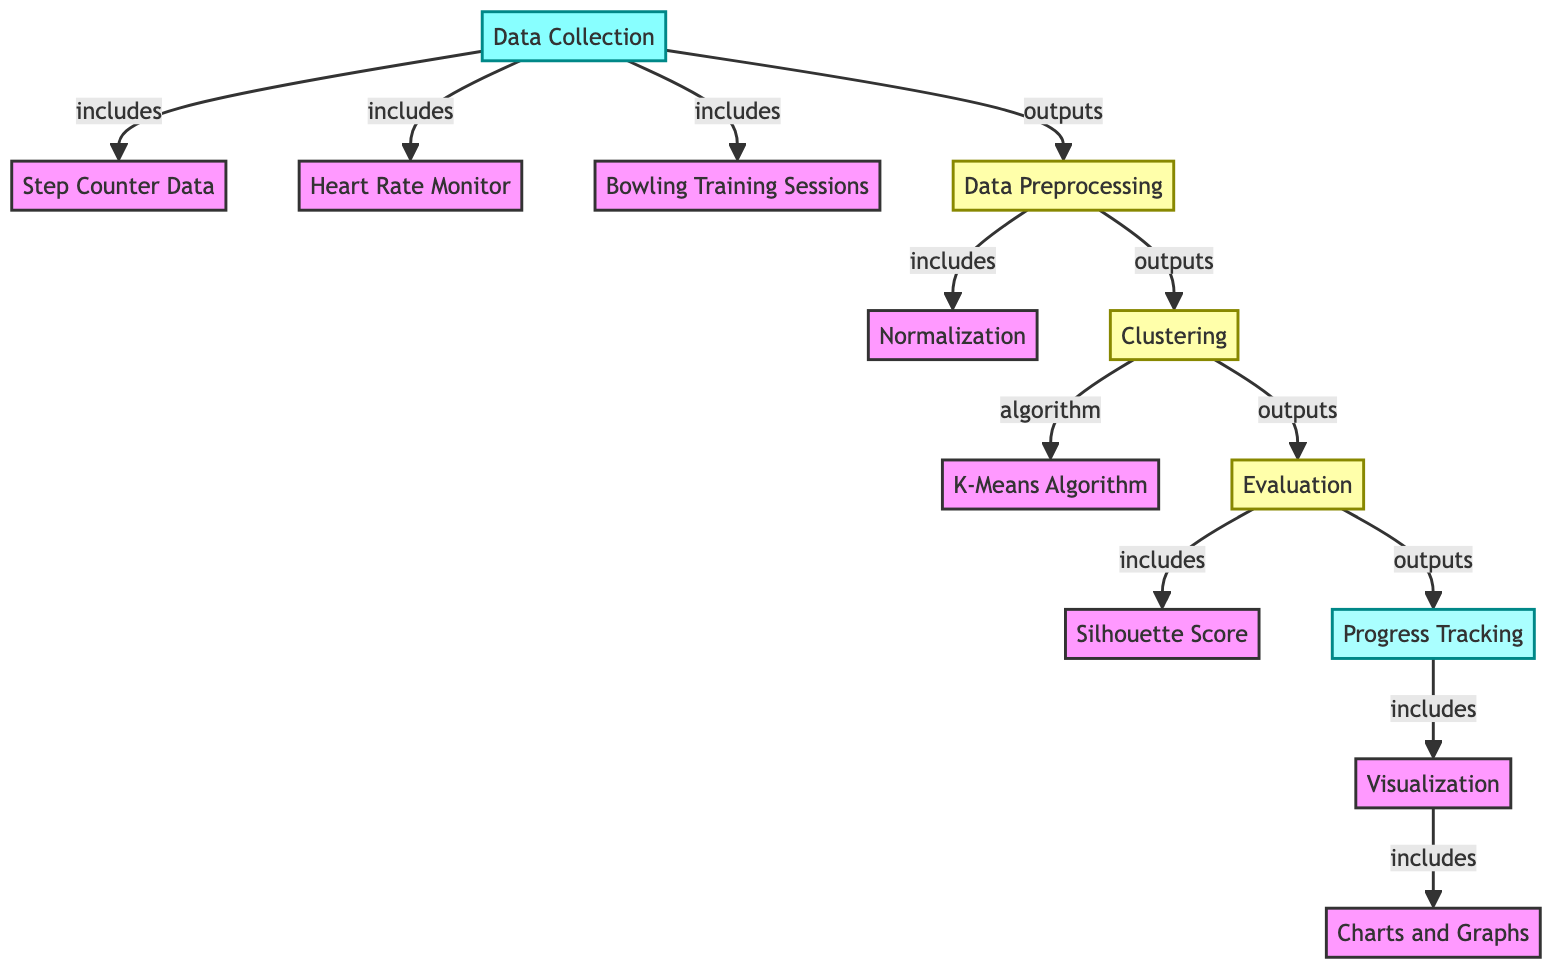What data sources are included in the data collection? The data collection node explicitly lists three sources: step counter data, heart rate monitor data, and bowling training sessions.
Answer: step counter data, heart rate monitor, bowling training sessions How many processing steps are indicated in the diagram? The diagram includes three process nodes: data preprocessing, clustering, and evaluation. Therefore, there are three processing steps in total.
Answer: three What is the output of the clustering step? The clustering step leads to the evaluation node, which indicates that this is the direct output of the clustering process.
Answer: evaluation Which algorithm is utilized in the clustering step? The diagram specifies that the K-Means algorithm is the method used during the clustering process, as indicated in the clustering node's flow.
Answer: K-Means Algorithm What is the purpose of the evaluation step? The evaluation step's purpose is to assess the clustering's effectiveness using metrics, one of which is the silhouette score, as shown in the diagram.
Answer: evaluation What type of visualization is included in the progress tracking? The progress tracking node specifies that charts and graphs are part of the visualization output, indicating the method of visual analysis.
Answer: charts and graphs How does data preprocessing relate to normalization? In the diagram, normalization is a subset included within the data preprocessing step, indicating that it is one of the tasks performed during data preprocessing.
Answer: includes What flows into the progress tracking node? The output from the evaluation step flows into the progress tracking node, signifying the progression of data processing.
Answer: evaluation How does the clustering node connect to evaluation? The clustering node leads directly to the evaluation node, establishing a one-way connection where the clustering results are assessed in the evaluation phase.
Answer: directly 